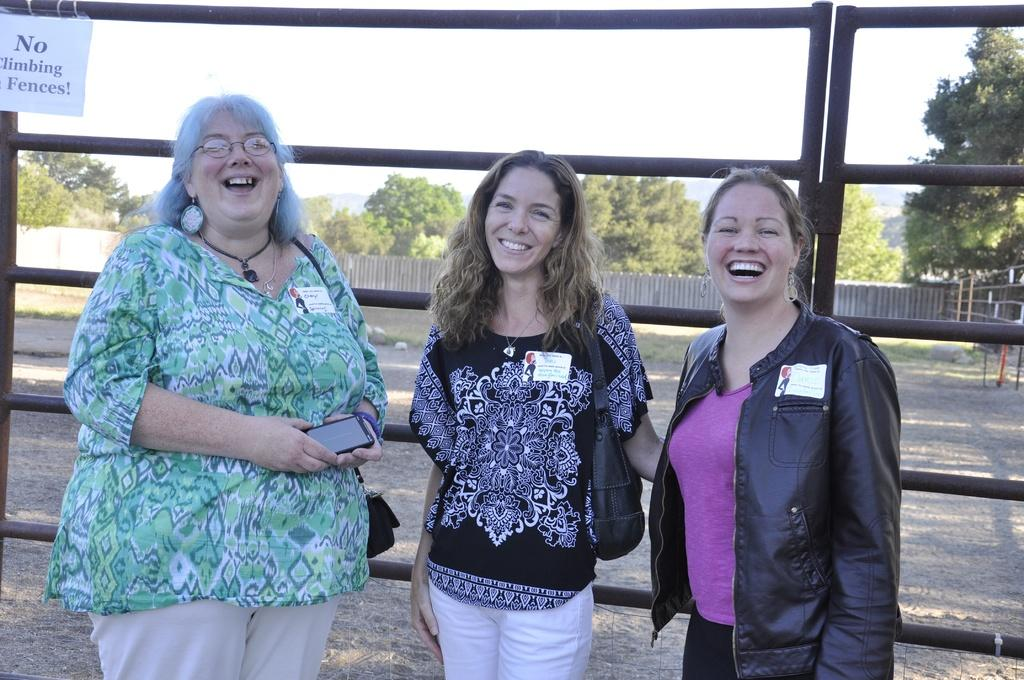What are the people in the image doing? The people in the image are standing and smiling. What is located behind the people? There is a fence behind the people. What can be seen in the background of the image? There are trees in the background. What is visible at the top of the image? The sky is visible at the top of the image. What language is the scarecrow speaking in the image? There is no scarecrow present in the image, so it is not possible to determine what language it might be speaking. Are there any stockings visible on the people in the image? There is no mention of stockings in the provided facts, so it cannot be determined if any are visible on the people in the image. 